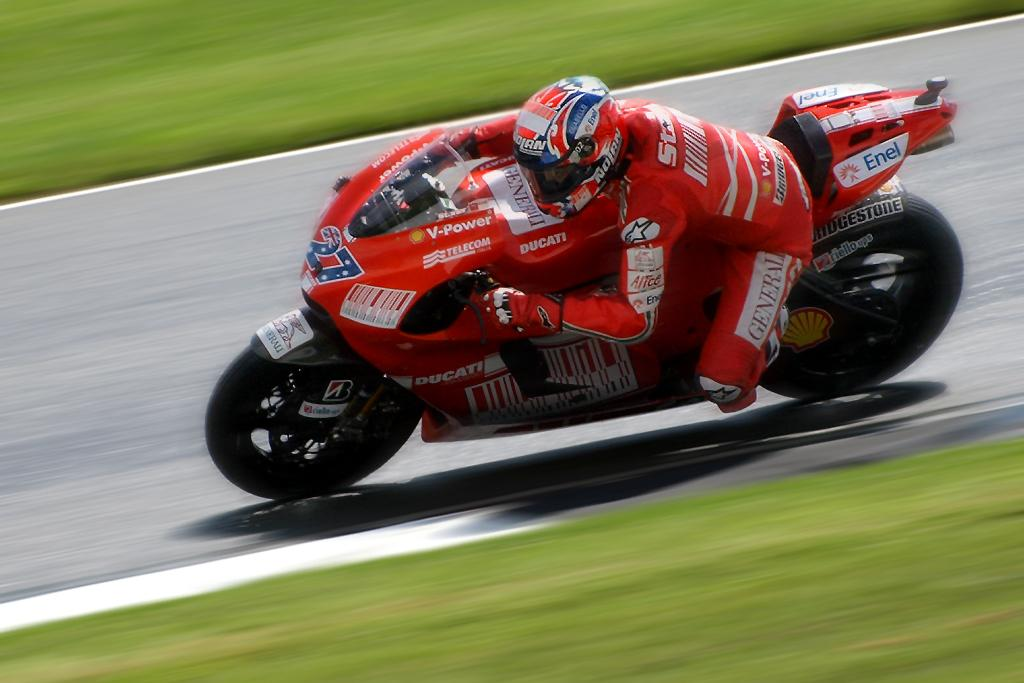What type of vegetation is present in the image? There is grass in the image. What mode of transportation can be seen in the image? There is a person riding a motorcycle in the image. Where is the stream located in the image? There is no stream present in the image; it only features grass and a person riding a motorcycle. What type of fruit is being harvested in the image? There is no fruit present in the image. 